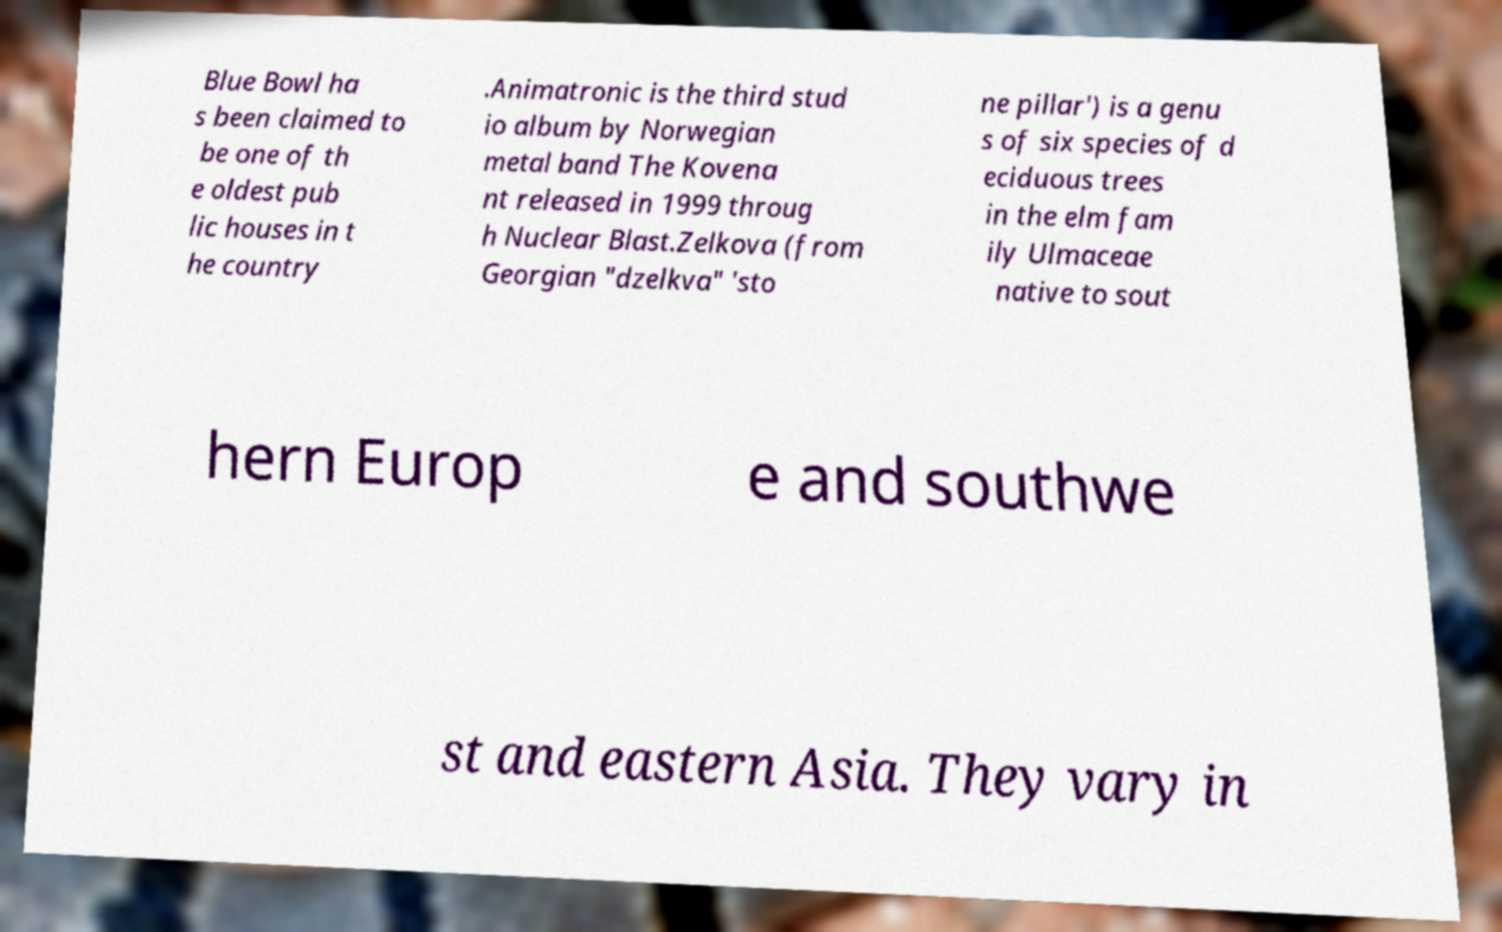What messages or text are displayed in this image? I need them in a readable, typed format. Blue Bowl ha s been claimed to be one of th e oldest pub lic houses in t he country .Animatronic is the third stud io album by Norwegian metal band The Kovena nt released in 1999 throug h Nuclear Blast.Zelkova (from Georgian "dzelkva" 'sto ne pillar') is a genu s of six species of d eciduous trees in the elm fam ily Ulmaceae native to sout hern Europ e and southwe st and eastern Asia. They vary in 